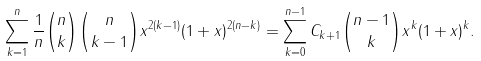Convert formula to latex. <formula><loc_0><loc_0><loc_500><loc_500>\sum _ { k = 1 } ^ { n } \frac { 1 } { n } { n \choose k } { n \choose k - 1 } x ^ { 2 ( k - 1 ) } ( 1 + x ) ^ { 2 ( n - k ) } = \sum _ { k = 0 } ^ { n - 1 } C _ { k + 1 } { n - 1 \choose k } x ^ { k } ( 1 + x ) ^ { k } .</formula> 